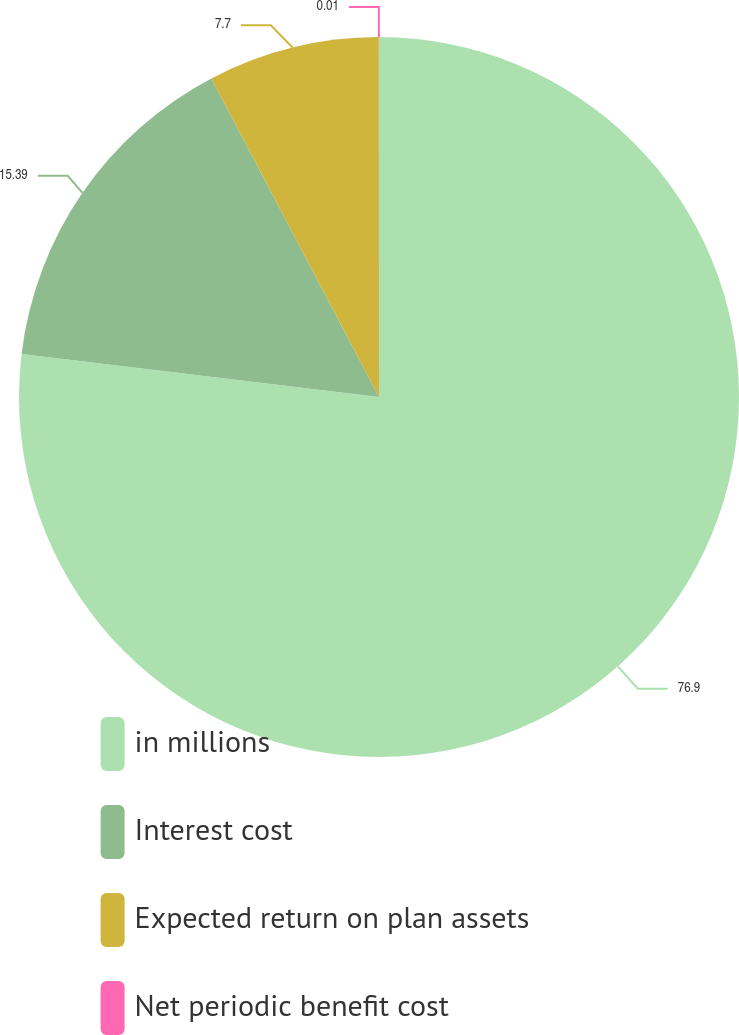<chart> <loc_0><loc_0><loc_500><loc_500><pie_chart><fcel>in millions<fcel>Interest cost<fcel>Expected return on plan assets<fcel>Net periodic benefit cost<nl><fcel>76.91%<fcel>15.39%<fcel>7.7%<fcel>0.01%<nl></chart> 